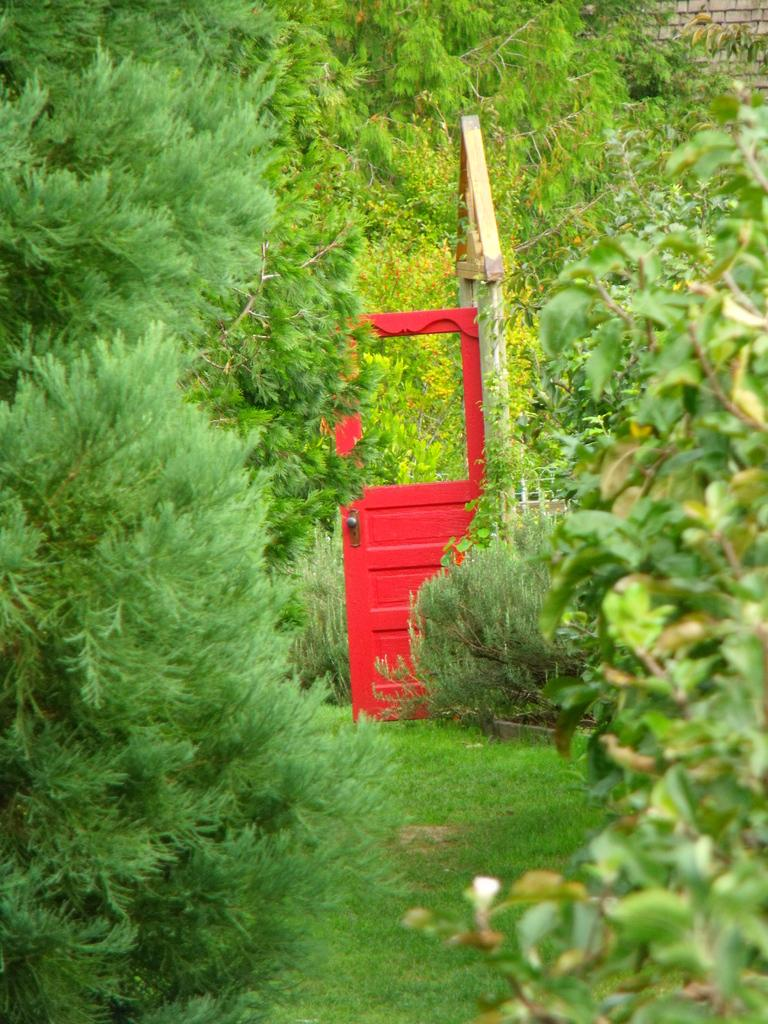What type of vegetation is present on the land in the image? There is grass on the land in the image. What is the color and location of the door in the image? There is a red door in the middle of the image. What can be seen in the background of the image? There are trees in the background of the image. How many rays are visible coming from the door in the image? There are no rays visible coming from the door in the image. Is there a prison visible in the image? There is no prison present in the image. 